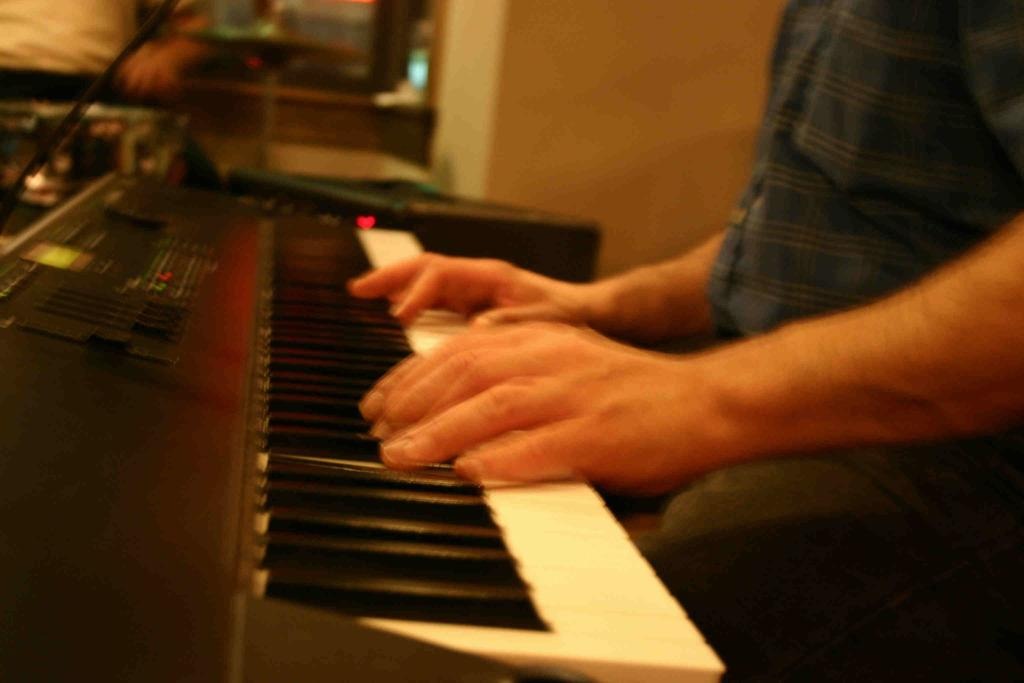Who is the main subject in the image? There is a man in the image. What is the man doing in the image? The man is seated and playing a piano. Can you describe the piano in the image? The piano has white and black keys. How many babies are crawling around the piano in the image? There are no babies present in the image; it only features a man playing a piano. What type of snails can be seen on the piano keys in the image? There are no snails present on the piano keys in the image; it only features a man playing a piano with white and black keys. 